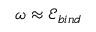Convert formula to latex. <formula><loc_0><loc_0><loc_500><loc_500>\omega \approx \mathcal { E } _ { b i n d }</formula> 